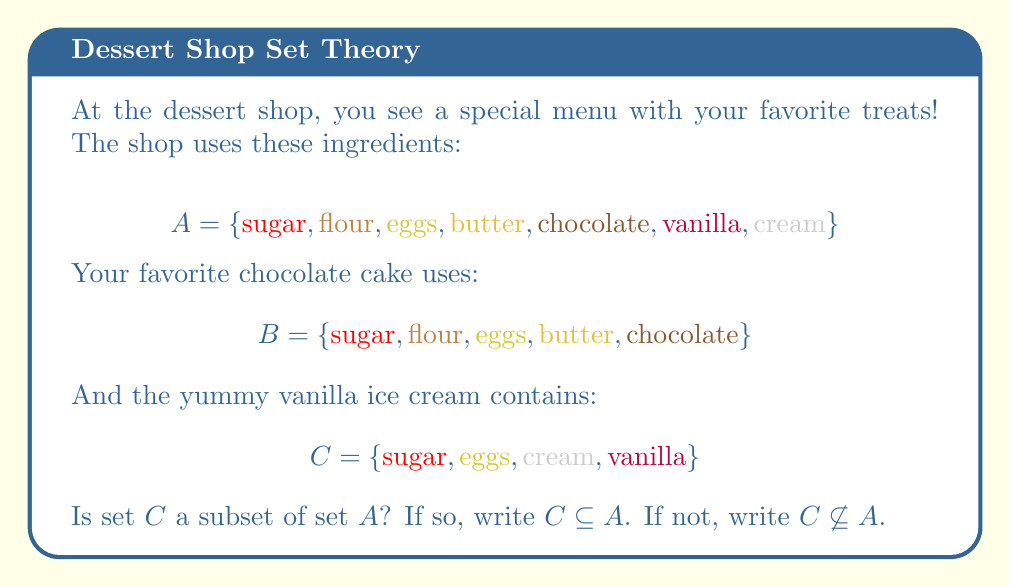What is the answer to this math problem? Let's approach this step-by-step:

1. To determine if $C$ is a subset of $A$, we need to check if every element in $C$ is also in $A$.

2. Let's check each element of $C$:
   - $\text{sugar}$ is in $A$
   - $\text{eggs}$ is in $A$
   - $\text{cream}$ is in $A$
   - $\text{vanilla}$ is in $A$

3. We can see that all elements of $C$ are indeed in $A$.

4. The definition of a subset states that if every element of set $C$ is also an element of set $A$, then $C$ is a subset of $A$.

5. Since all elements of $C$ are in $A$, we can conclude that $C$ is a subset of $A$.

Therefore, we write $C \subseteq A$ to show that $C$ is a subset of $A$.
Answer: $C \subseteq A$ 